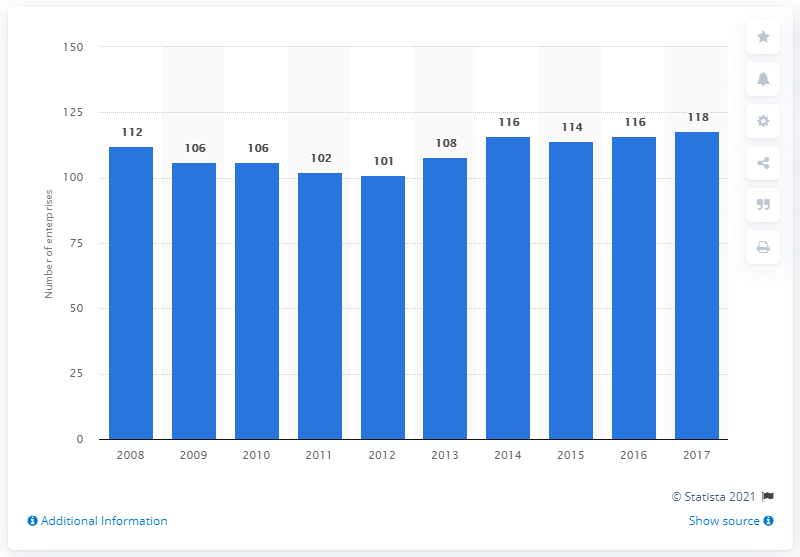Identify some key points in this picture. In 2017, there were 118 enterprises in Estonia that manufactured computer, electronic, and optical products. 